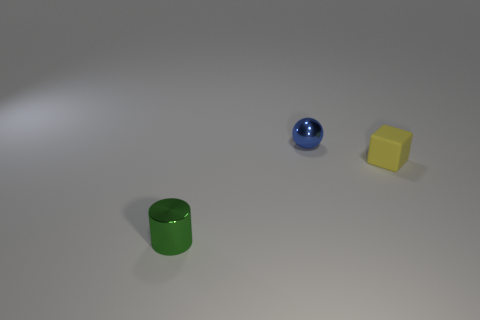Add 1 yellow blocks. How many objects exist? 4 Subtract all cylinders. How many objects are left? 2 Subtract 0 blue cylinders. How many objects are left? 3 Subtract all tiny green objects. Subtract all small rubber things. How many objects are left? 1 Add 2 tiny yellow cubes. How many tiny yellow cubes are left? 3 Add 2 small gray metallic spheres. How many small gray metallic spheres exist? 2 